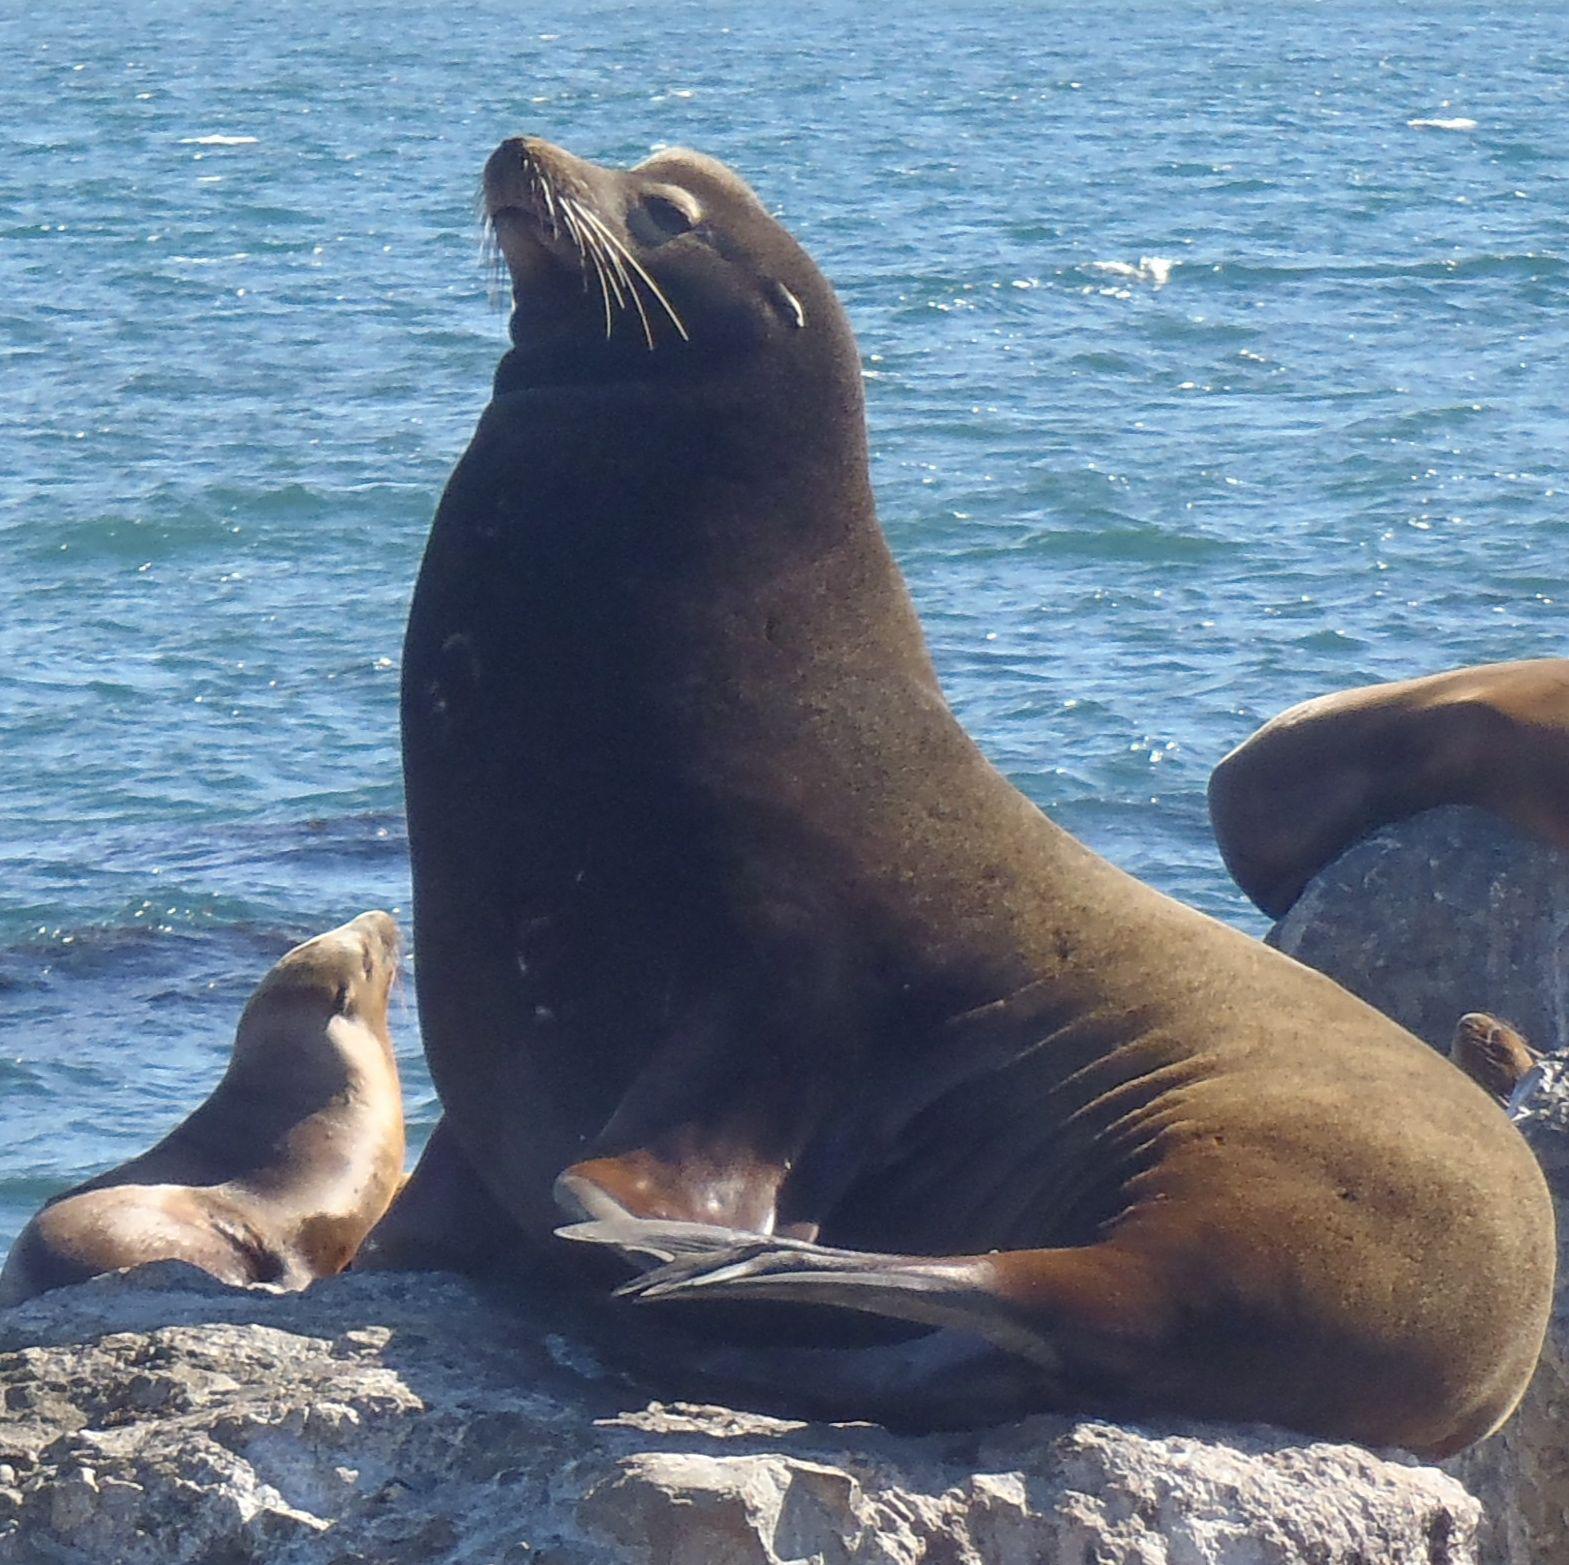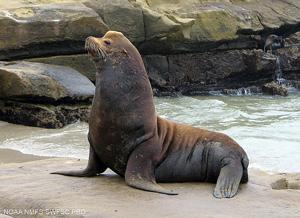The first image is the image on the left, the second image is the image on the right. For the images shown, is this caption "There are exactly two animals in the image on the right." true? Answer yes or no. No. 